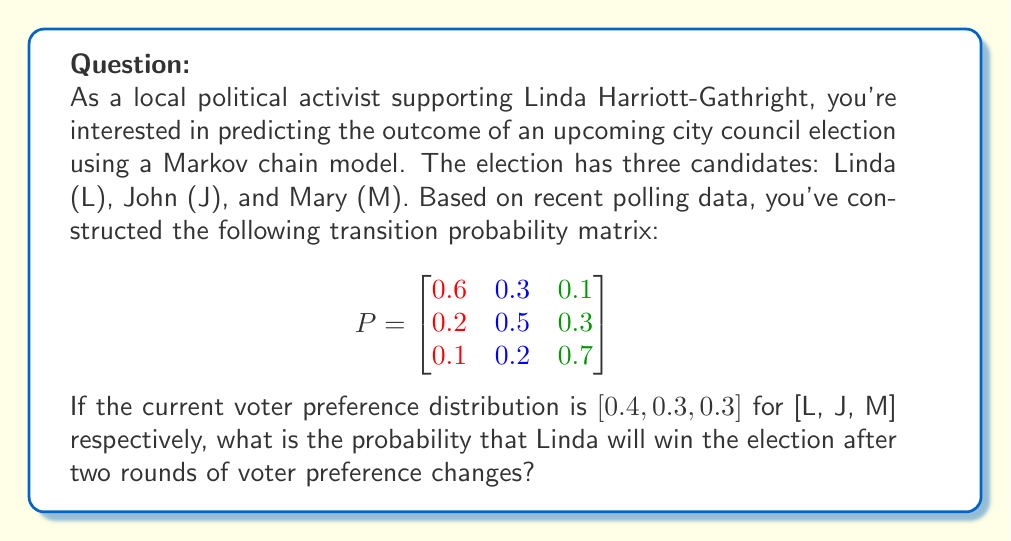Give your solution to this math problem. To solve this problem, we'll use the Markov chain model to predict the voter preference distribution after two rounds of changes. Then, we'll determine the probability of Linda winning.

Step 1: Define the initial state vector
Let $x_0 = [0.4, 0.3, 0.3]$ be the initial voter preference distribution.

Step 2: Calculate the voter preference distribution after one round
$x_1 = x_0 P$
$x_1 = [0.4, 0.3, 0.3] \begin{bmatrix}
0.6 & 0.3 & 0.1 \\
0.2 & 0.5 & 0.3 \\
0.1 & 0.2 & 0.7
\end{bmatrix}$

$x_1 = [0.34, 0.33, 0.33]$

Step 3: Calculate the voter preference distribution after two rounds
$x_2 = x_1 P$
$x_2 = [0.34, 0.33, 0.33] \begin{bmatrix}
0.6 & 0.3 & 0.1 \\
0.2 & 0.5 & 0.3 \\
0.1 & 0.2 & 0.7
\end{bmatrix}$

$x_2 = [0.323, 0.335, 0.342]$

Step 4: Determine the probability of Linda winning
Linda wins if her voter preference is higher than both John's and Mary's. In this case, Linda's preference (0.323) is lower than both John's (0.335) and Mary's (0.342).

Therefore, the probability of Linda winning after two rounds is 0.
Answer: 0 